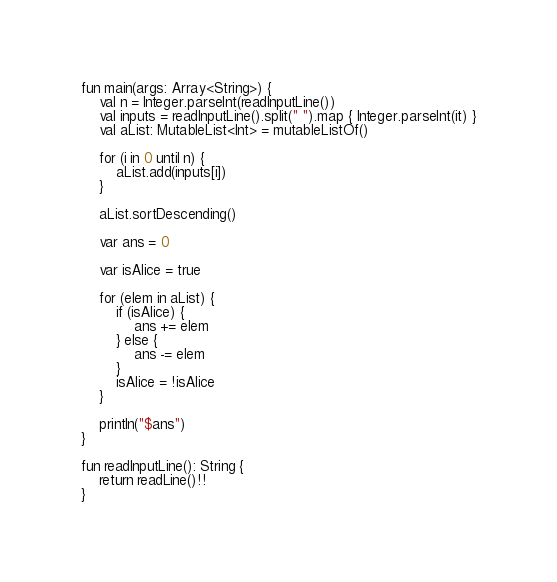Convert code to text. <code><loc_0><loc_0><loc_500><loc_500><_Kotlin_>fun main(args: Array<String>) {
    val n = Integer.parseInt(readInputLine())
    val inputs = readInputLine().split(" ").map { Integer.parseInt(it) }
    val aList: MutableList<Int> = mutableListOf()
    
    for (i in 0 until n) {
        aList.add(inputs[i])
    }
    
    aList.sortDescending()

    var ans = 0
    
    var isAlice = true
    
    for (elem in aList) {
        if (isAlice) {
            ans += elem
        } else {
            ans -= elem
        }
        isAlice = !isAlice
    }
    
    println("$ans")
}

fun readInputLine(): String {
    return readLine()!!
}
</code> 